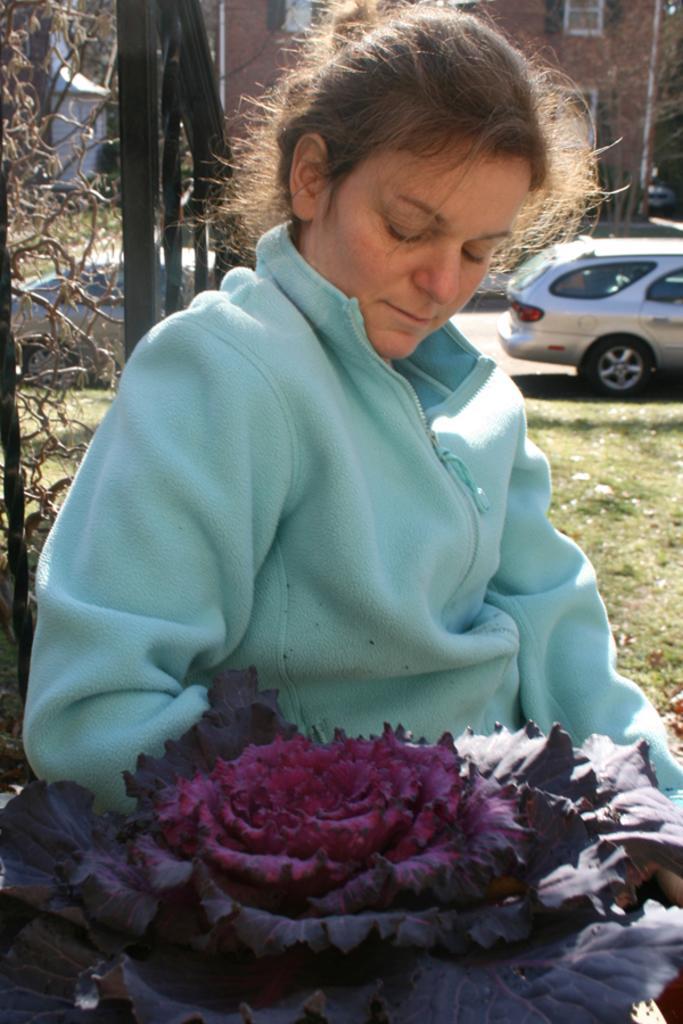Describe this image in one or two sentences. In this picture I can see a woman in front and I see that, she is wearing a blue color jacket and side to her, I can see a plant and I can see a flower on it. In the background I can see the fencing, grass, a car and a building. 